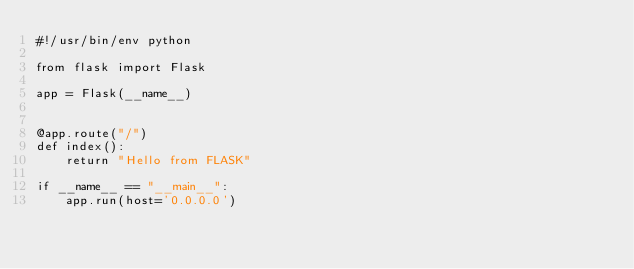Convert code to text. <code><loc_0><loc_0><loc_500><loc_500><_Python_>#!/usr/bin/env python

from flask import Flask

app = Flask(__name__)


@app.route("/")
def index():
    return "Hello from FLASK"

if __name__ == "__main__":
    app.run(host='0.0.0.0')
</code> 